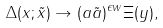Convert formula to latex. <formula><loc_0><loc_0><loc_500><loc_500>\Delta ( x ; \tilde { x } ) \rightarrow ( a \tilde { a } ) ^ { \epsilon w } \Xi ( y ) ,</formula> 